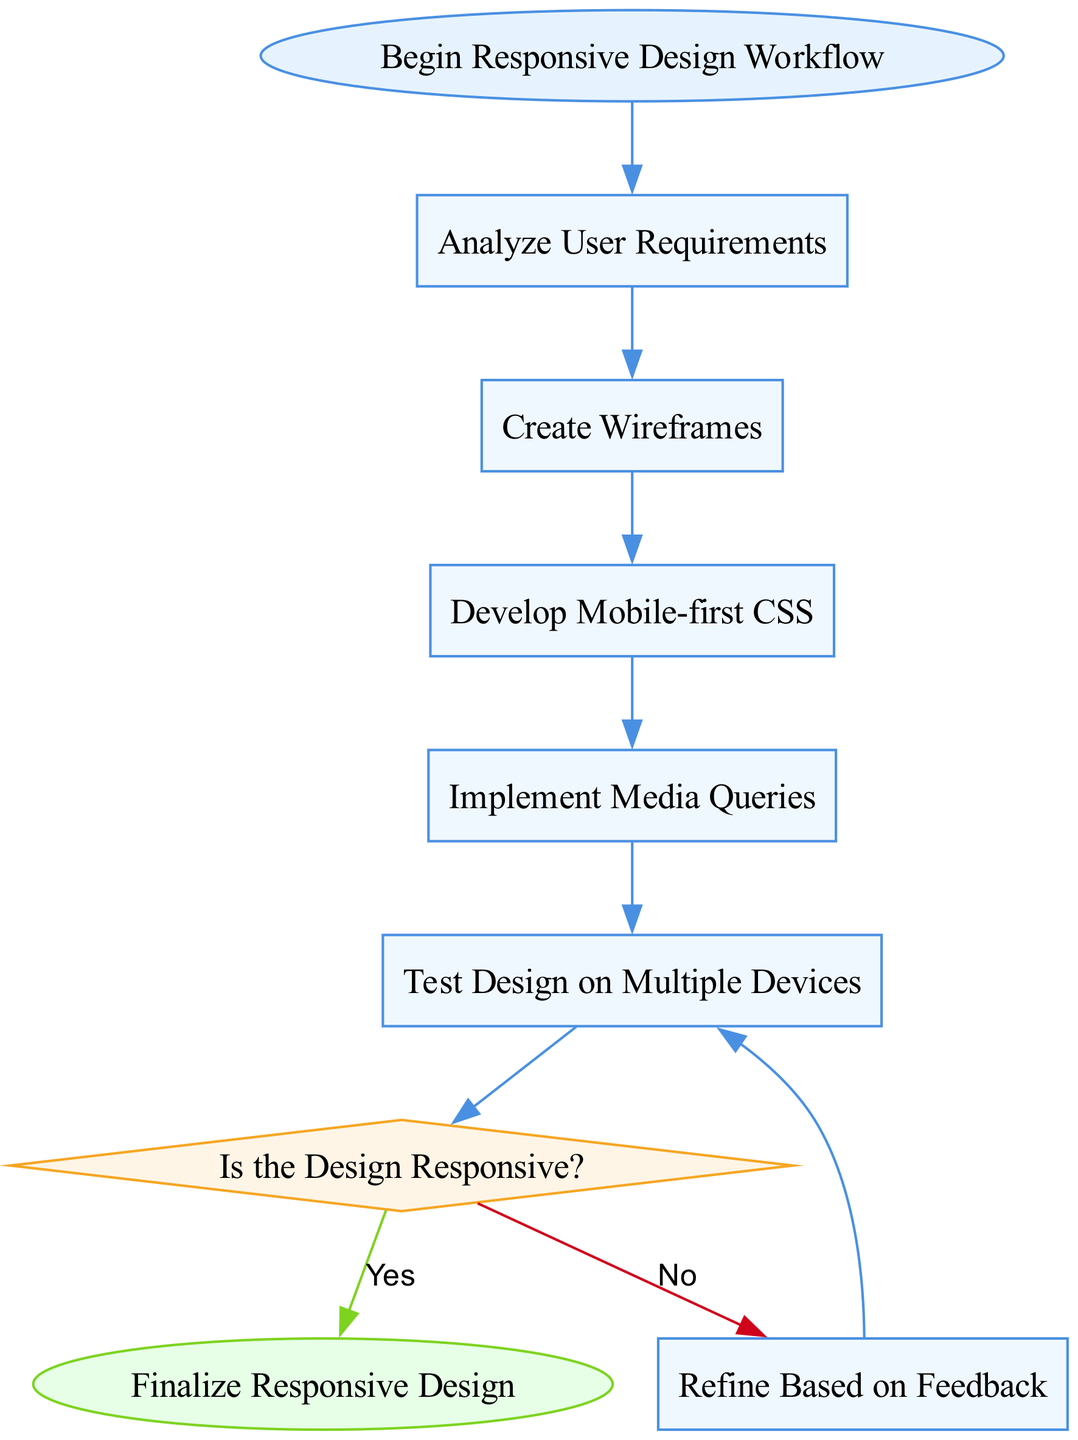What is the first step in the workflow? The first step is labeled "Begin Responsive Design Workflow," which is the starting point of the process.
Answer: Begin Responsive Design Workflow How many process nodes are in the diagram? There are five process nodes in the diagram, which include "Analyze User Requirements," "Create Wireframes," "Develop Mobile-first CSS," "Implement Media Queries," and "Test Design on Multiple Devices."
Answer: 5 What decision is made after testing the design? The decision made is "Is the Design Responsive?" which determines if the design meets responsiveness standards after testing.
Answer: Is the Design Responsive? What happens if the design is not responsive? If the design is not responsive (condition "No"), the process leads to "Refine Based on Feedback," prompting further iterations to improve the design.
Answer: Refine Based on Feedback What is the final step in the workflow? The final step is labeled "Finalize Responsive Design," which indicates the conclusion of the workflow after making any necessary refinements.
Answer: Finalize Responsive Design How many total nodes are in the diagram? The total number of nodes is nine, including start, process, decision, and end nodes.
Answer: 9 What is the color of decision nodes in the diagram? The decision nodes are filled with the color "#FFF5E6," denoting them distinctly from process and start/end nodes.
Answer: #FFF5E6 What do you do after "Test Design on Multiple Devices"? After testing the design on multiple devices, the next step is to make a decision on whether the design is responsive or not.
Answer: Is the Design Responsive? 